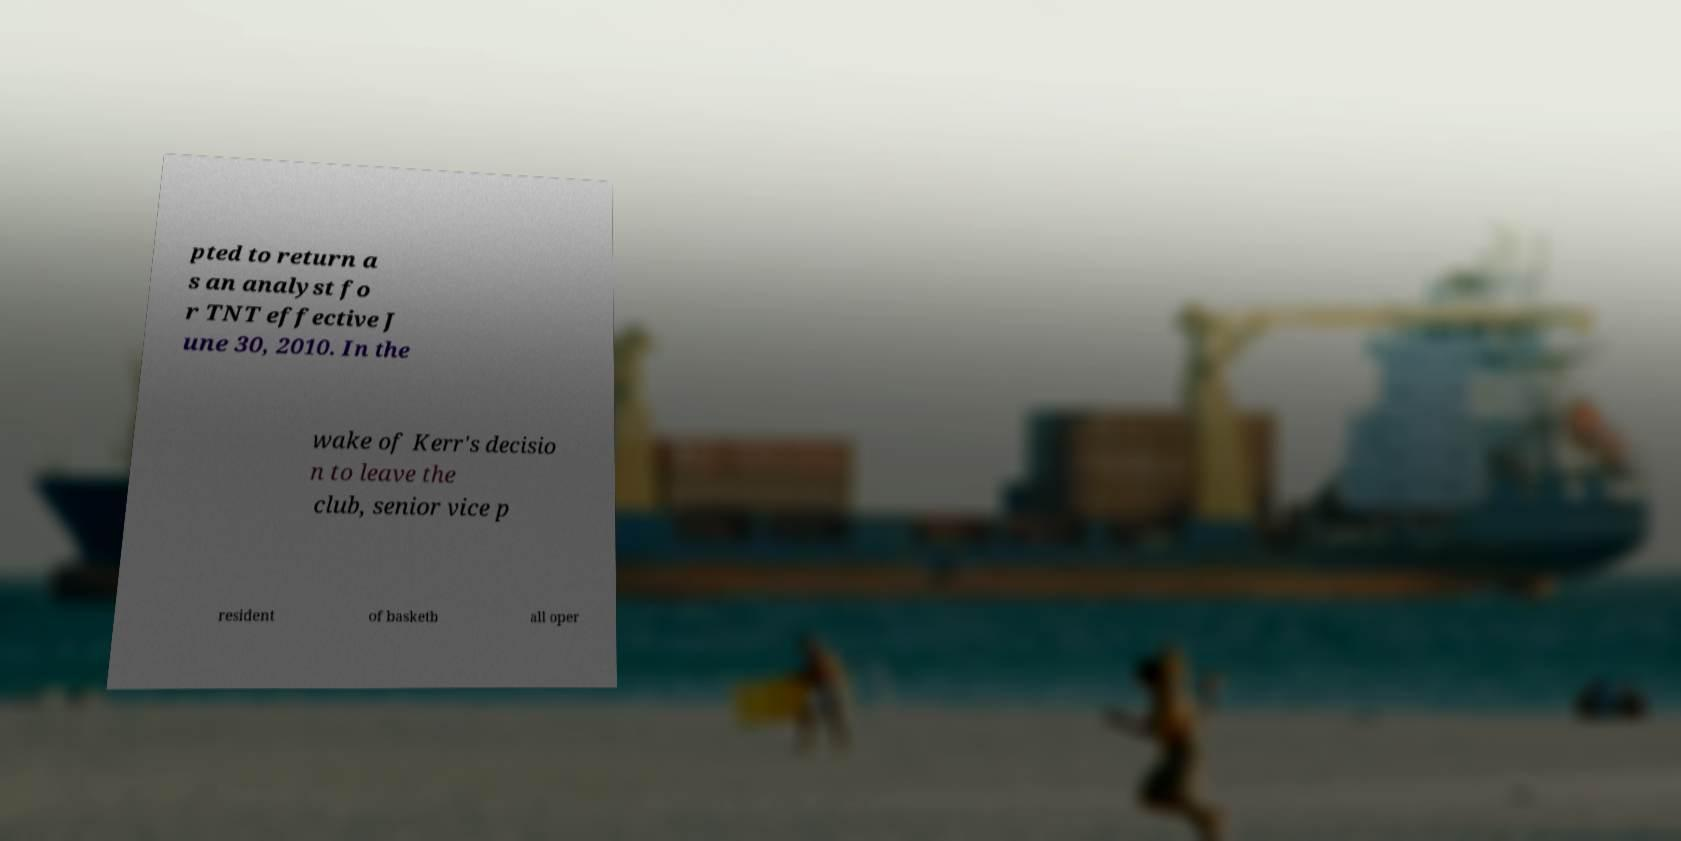Could you extract and type out the text from this image? pted to return a s an analyst fo r TNT effective J une 30, 2010. In the wake of Kerr's decisio n to leave the club, senior vice p resident of basketb all oper 